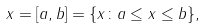<formula> <loc_0><loc_0><loc_500><loc_500>x = [ a , b ] = \{ x \colon a \leq x \leq b \} ,</formula> 